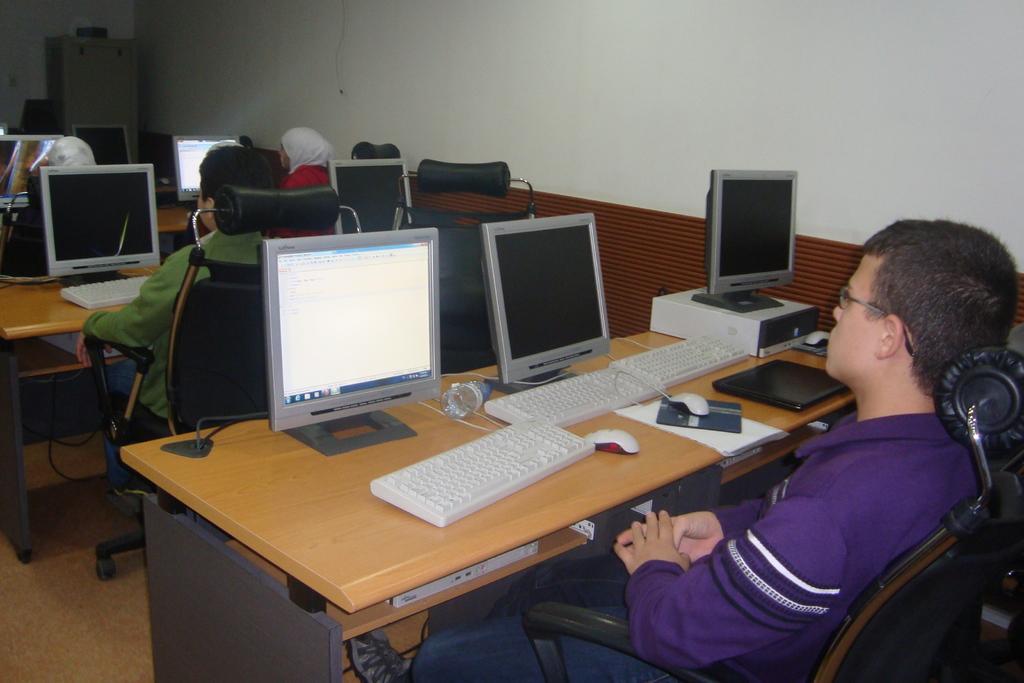Please provide a concise description of this image. In this image we can see a man is sitting on a chair. In front of the man, we can see a table. On the table, we can see keyboards, mouses, monitors, laptop, papers, bottle and one object. At the top of the image, we can see a wall. On the left side of the image, we can see one more person is sitting on the chair. In front of the person, we can see the monitor and keyboard. In the background, we can see women, monitors, chairs and a cupboard. We can see floor in the left bottom of the image. 